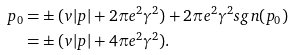<formula> <loc_0><loc_0><loc_500><loc_500>p _ { 0 } = & \pm ( v | p | + 2 \pi e ^ { 2 } \gamma ^ { 2 } ) + 2 \pi e ^ { 2 } \gamma ^ { 2 } s g n ( p _ { 0 } ) \\ = & \pm ( v | p | + 4 \pi e ^ { 2 } \gamma ^ { 2 } ) .</formula> 